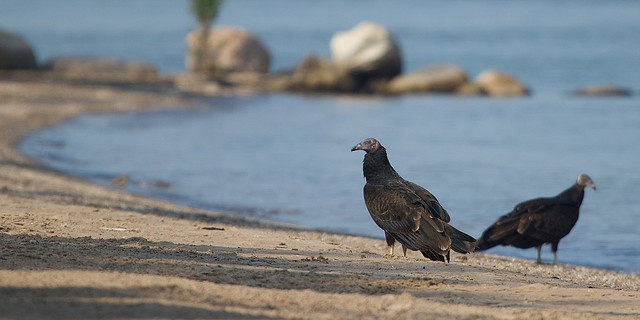Describe the objects in this image and their specific colors. I can see bird in gray and black tones and bird in gray and black tones in this image. 